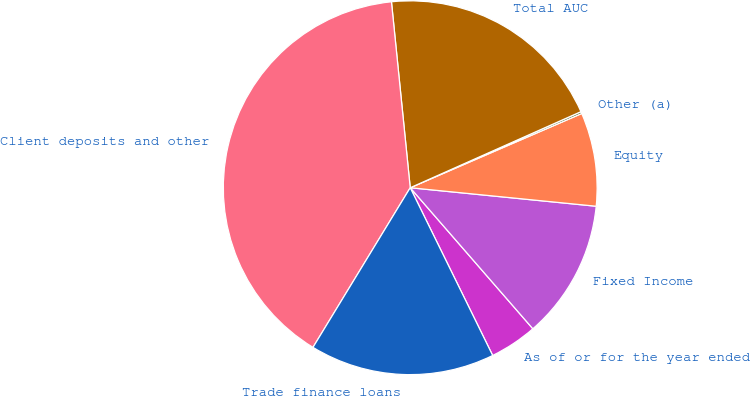Convert chart to OTSL. <chart><loc_0><loc_0><loc_500><loc_500><pie_chart><fcel>As of or for the year ended<fcel>Fixed Income<fcel>Equity<fcel>Other (a)<fcel>Total AUC<fcel>Client deposits and other<fcel>Trade finance loans<nl><fcel>4.12%<fcel>12.03%<fcel>8.08%<fcel>0.17%<fcel>19.93%<fcel>39.69%<fcel>15.98%<nl></chart> 